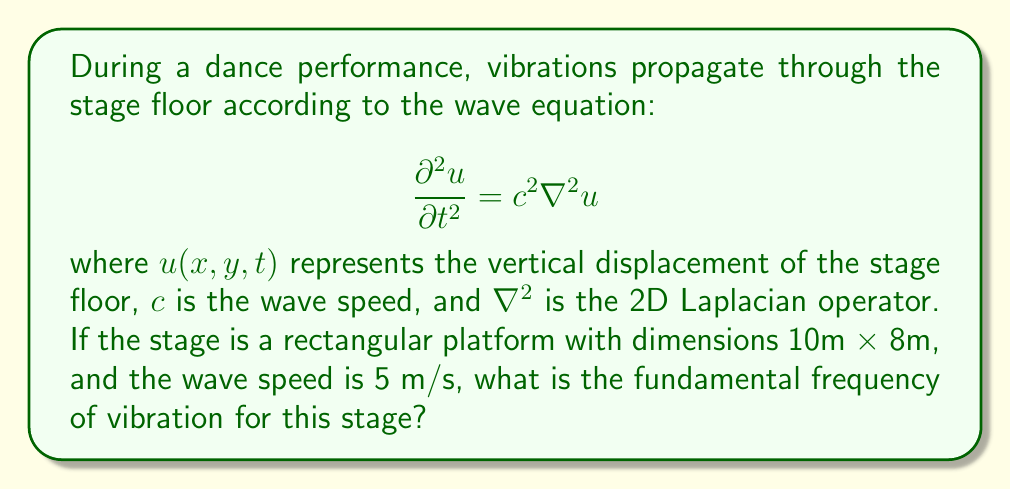Help me with this question. To solve this problem, we'll follow these steps:

1) The fundamental frequency of vibration for a rectangular membrane (which we can consider our stage to be) is given by:

   $$f = \frac{c}{2} \sqrt{\left(\frac{1}{L_x}\right)^2 + \left(\frac{1}{L_y}\right)^2}$$

   where $c$ is the wave speed, and $L_x$ and $L_y$ are the dimensions of the rectangle.

2) We're given:
   $c = 5$ m/s
   $L_x = 10$ m
   $L_y = 8$ m

3) Let's substitute these values into our equation:

   $$f = \frac{5}{2} \sqrt{\left(\frac{1}{10}\right)^2 + \left(\frac{1}{8}\right)^2}$$

4) Simplify inside the square root:

   $$f = \frac{5}{2} \sqrt{\frac{1}{100} + \frac{1}{64}}$$

5) Add the fractions:

   $$f = \frac{5}{2} \sqrt{\frac{64 + 100}{6400}} = \frac{5}{2} \sqrt{\frac{164}{6400}}$$

6) Simplify:

   $$f = \frac{5}{2} \sqrt{\frac{41}{1600}} = \frac{5}{2} \cdot \frac{\sqrt{41}}{40} = \frac{5\sqrt{41}}{80}$$

7) This can be approximated to a decimal:

   $$f \approx 0.3992$$ Hz
Answer: $\frac{5\sqrt{41}}{80}$ Hz (≈ 0.3992 Hz) 